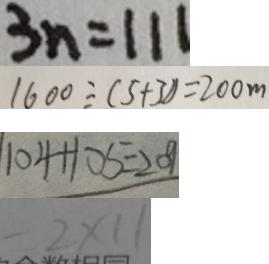Convert formula to latex. <formula><loc_0><loc_0><loc_500><loc_500>3 n = 1 1 1 
 1 6 0 0 \div ( 5 + 3 ) ) = 2 0 0 m 
 1 0 4 + 1 0 5 = 2 0 9 
 - 2 \times 1 1</formula> 